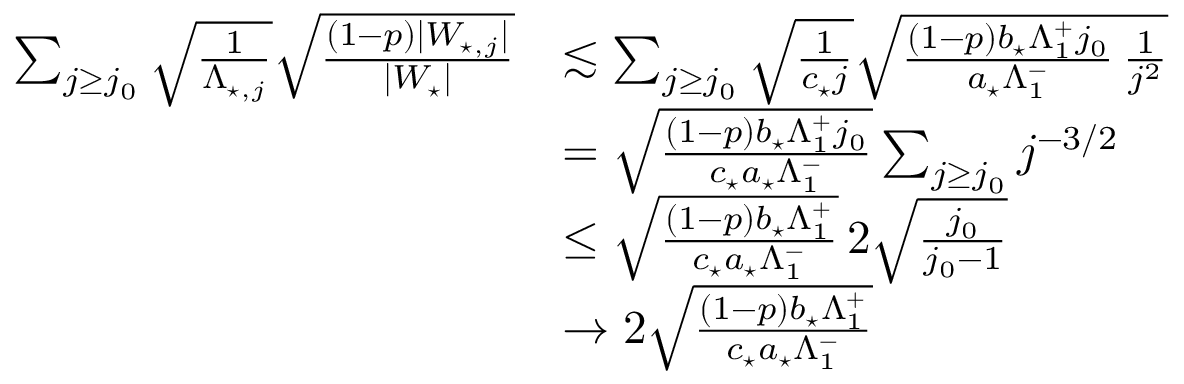<formula> <loc_0><loc_0><loc_500><loc_500>\begin{array} { r l } { \sum _ { j \geq j _ { 0 } } \sqrt { \frac { 1 } { \Lambda _ { ^ { * } , j } } } \sqrt { \frac { ( 1 - p ) | W _ { ^ { * } , j } | } { | W _ { ^ { * } } | } } } & { \lesssim \sum _ { j \geq j _ { 0 } } \sqrt { \frac { 1 } { c _ { ^ { * } } j } } \sqrt { \frac { ( 1 - p ) b _ { ^ { * } } \Lambda _ { 1 } ^ { + } j _ { 0 } } { a _ { ^ { * } } \Lambda _ { 1 } ^ { - } } \, \frac { 1 } { j ^ { 2 } } } } \\ & { = \sqrt { } ( 1 - p ) b _ { ^ { * } } \Lambda _ { 1 } ^ { + } j _ { 0 } } { c _ { ^ { * } } a _ { ^ { * } } \Lambda _ { 1 } ^ { - } } \sum _ { j \geq j _ { 0 } } j ^ { - 3 / 2 } } \\ & { \leq \sqrt { } ( 1 - p ) b _ { ^ { * } } \Lambda _ { 1 } ^ { + } } { c _ { ^ { * } } a _ { ^ { * } } \Lambda _ { 1 } ^ { - } } \, 2 \sqrt { \frac { j _ { 0 } } { j _ { 0 } - 1 } } } \\ & { \to 2 \sqrt { } ( 1 - p ) b _ { ^ { * } } \Lambda _ { 1 } ^ { + } } { c _ { ^ { * } } a _ { ^ { * } } \Lambda _ { 1 } ^ { - } } } \end{array}</formula> 